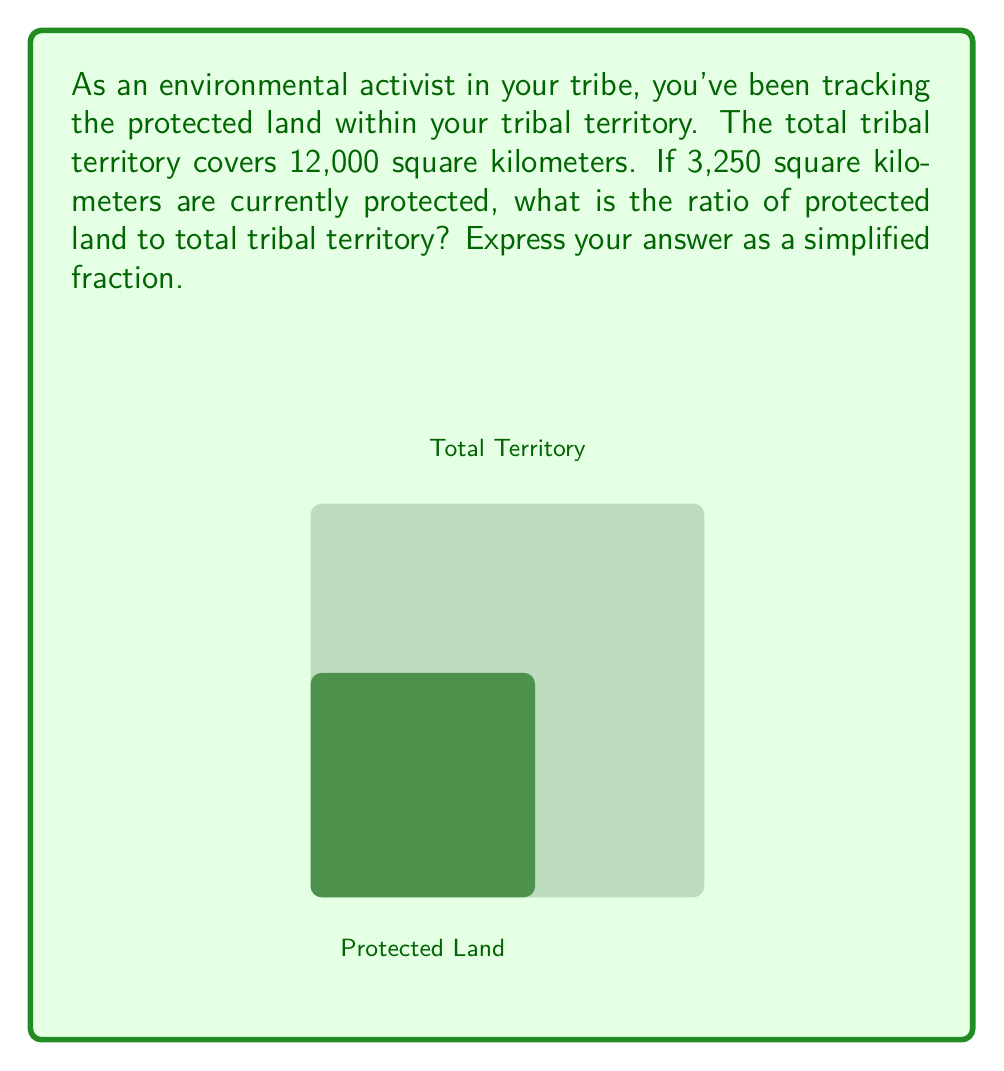Could you help me with this problem? Let's approach this step-by-step:

1) We need to create a ratio of protected land to total tribal territory.

2) Protected land = 3,250 sq km
   Total tribal territory = 12,000 sq km

3) The ratio can be written as:
   $$\frac{\text{Protected Land}}{\text{Total Territory}} = \frac{3,250}{12,000}$$

4) To simplify this fraction, we need to find the greatest common divisor (GCD) of 3,250 and 12,000.
   
   We can factor these numbers:
   3,250 = 2 × 5² × 13
   12,000 = 2⁴ × 3 × 5³

   The GCD is 2 × 5² = 50

5) Dividing both the numerator and denominator by 50:

   $$\frac{3,250 ÷ 50}{12,000 ÷ 50} = \frac{65}{240}$$

This fraction cannot be simplified further.
Answer: $\frac{65}{240}$ 